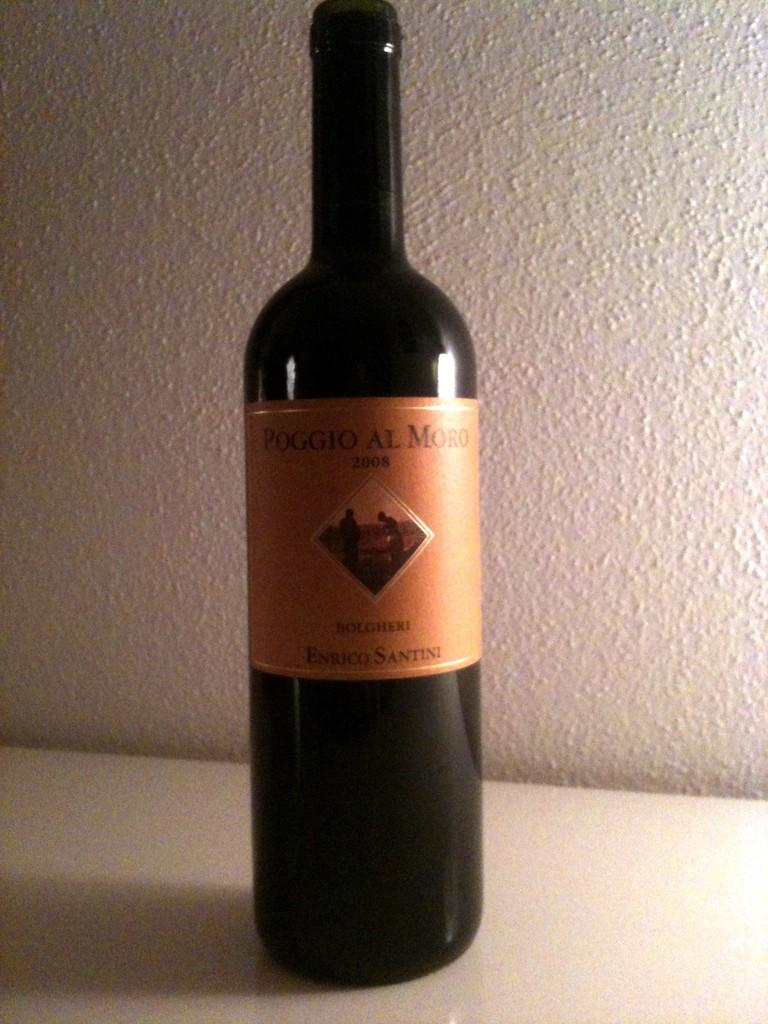<image>
Write a terse but informative summary of the picture. A bottle of Poggio Al Moro is sitting on a counter. 